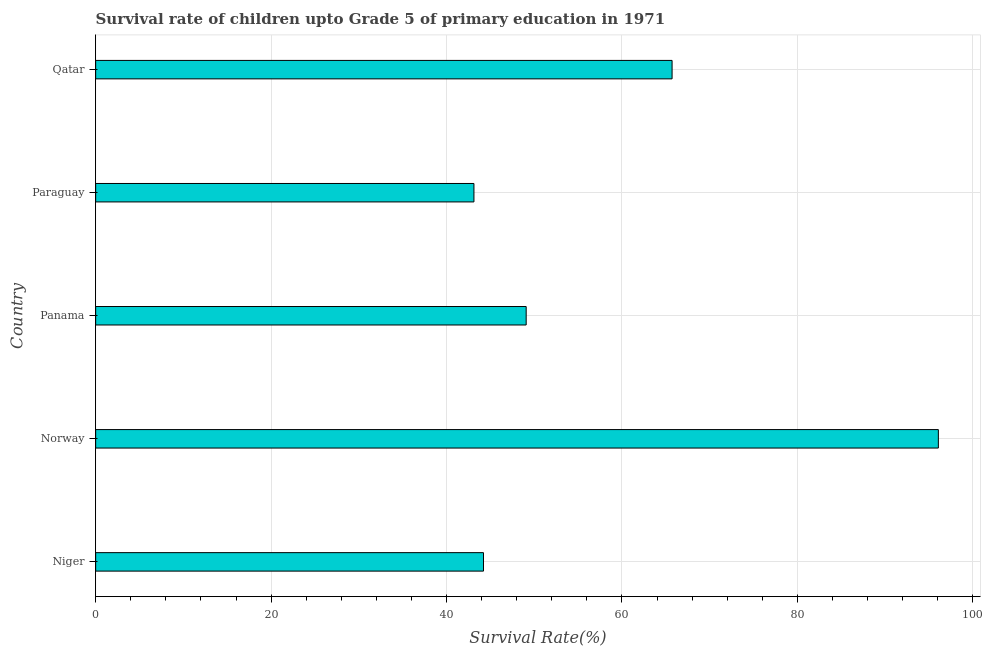Does the graph contain any zero values?
Your answer should be very brief. No. Does the graph contain grids?
Keep it short and to the point. Yes. What is the title of the graph?
Ensure brevity in your answer.  Survival rate of children upto Grade 5 of primary education in 1971 . What is the label or title of the X-axis?
Your answer should be very brief. Survival Rate(%). What is the label or title of the Y-axis?
Your answer should be very brief. Country. What is the survival rate in Niger?
Your answer should be compact. 44.21. Across all countries, what is the maximum survival rate?
Ensure brevity in your answer.  96.07. Across all countries, what is the minimum survival rate?
Keep it short and to the point. 43.12. In which country was the survival rate maximum?
Provide a succinct answer. Norway. In which country was the survival rate minimum?
Ensure brevity in your answer.  Paraguay. What is the sum of the survival rate?
Offer a terse response. 298.2. What is the difference between the survival rate in Norway and Qatar?
Offer a very short reply. 30.36. What is the average survival rate per country?
Ensure brevity in your answer.  59.64. What is the median survival rate?
Provide a short and direct response. 49.08. In how many countries, is the survival rate greater than 80 %?
Make the answer very short. 1. What is the ratio of the survival rate in Niger to that in Qatar?
Provide a succinct answer. 0.67. Is the difference between the survival rate in Niger and Qatar greater than the difference between any two countries?
Your answer should be very brief. No. What is the difference between the highest and the second highest survival rate?
Provide a succinct answer. 30.36. Is the sum of the survival rate in Norway and Qatar greater than the maximum survival rate across all countries?
Your answer should be compact. Yes. What is the difference between the highest and the lowest survival rate?
Offer a terse response. 52.95. How many countries are there in the graph?
Your response must be concise. 5. Are the values on the major ticks of X-axis written in scientific E-notation?
Provide a succinct answer. No. What is the Survival Rate(%) in Niger?
Keep it short and to the point. 44.21. What is the Survival Rate(%) in Norway?
Ensure brevity in your answer.  96.07. What is the Survival Rate(%) of Panama?
Give a very brief answer. 49.08. What is the Survival Rate(%) in Paraguay?
Offer a very short reply. 43.12. What is the Survival Rate(%) in Qatar?
Make the answer very short. 65.71. What is the difference between the Survival Rate(%) in Niger and Norway?
Your response must be concise. -51.86. What is the difference between the Survival Rate(%) in Niger and Panama?
Provide a short and direct response. -4.87. What is the difference between the Survival Rate(%) in Niger and Paraguay?
Keep it short and to the point. 1.09. What is the difference between the Survival Rate(%) in Niger and Qatar?
Offer a very short reply. -21.5. What is the difference between the Survival Rate(%) in Norway and Panama?
Offer a very short reply. 46.99. What is the difference between the Survival Rate(%) in Norway and Paraguay?
Make the answer very short. 52.95. What is the difference between the Survival Rate(%) in Norway and Qatar?
Provide a short and direct response. 30.36. What is the difference between the Survival Rate(%) in Panama and Paraguay?
Make the answer very short. 5.96. What is the difference between the Survival Rate(%) in Panama and Qatar?
Give a very brief answer. -16.63. What is the difference between the Survival Rate(%) in Paraguay and Qatar?
Your answer should be very brief. -22.59. What is the ratio of the Survival Rate(%) in Niger to that in Norway?
Make the answer very short. 0.46. What is the ratio of the Survival Rate(%) in Niger to that in Panama?
Ensure brevity in your answer.  0.9. What is the ratio of the Survival Rate(%) in Niger to that in Paraguay?
Give a very brief answer. 1.02. What is the ratio of the Survival Rate(%) in Niger to that in Qatar?
Offer a very short reply. 0.67. What is the ratio of the Survival Rate(%) in Norway to that in Panama?
Give a very brief answer. 1.96. What is the ratio of the Survival Rate(%) in Norway to that in Paraguay?
Your answer should be very brief. 2.23. What is the ratio of the Survival Rate(%) in Norway to that in Qatar?
Keep it short and to the point. 1.46. What is the ratio of the Survival Rate(%) in Panama to that in Paraguay?
Offer a very short reply. 1.14. What is the ratio of the Survival Rate(%) in Panama to that in Qatar?
Make the answer very short. 0.75. What is the ratio of the Survival Rate(%) in Paraguay to that in Qatar?
Provide a short and direct response. 0.66. 